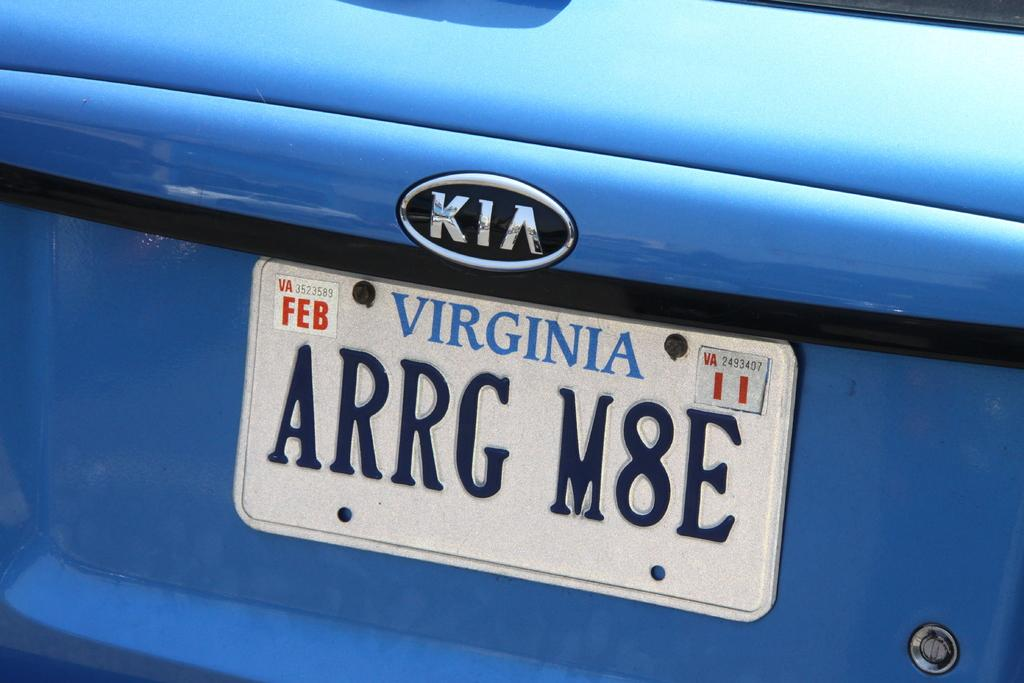Provide a one-sentence caption for the provided image. The blue KIA has license plate ARRG M8E and is registered in Virginia. 